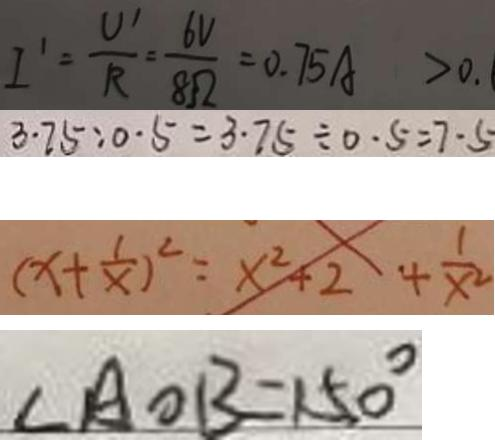Convert formula to latex. <formula><loc_0><loc_0><loc_500><loc_500>I ^ { \prime } = \frac { U ^ { \prime } } { R } = \frac { 6 V } { 8 \Omega } = 0 . 7 5 A > 0 . 
 3 . 7 5 : 0 . 5 = 3 . 7 5 \div 0 . 5 = 7 \cdot 5 
 ( x + \frac { 1 } { x } ) ^ { 2 } = x ^ { 2 } + 2 + \frac { 1 } { x ^ { 2 } } 
 \angle A O B = 1 5 0 ^ { \circ }</formula> 